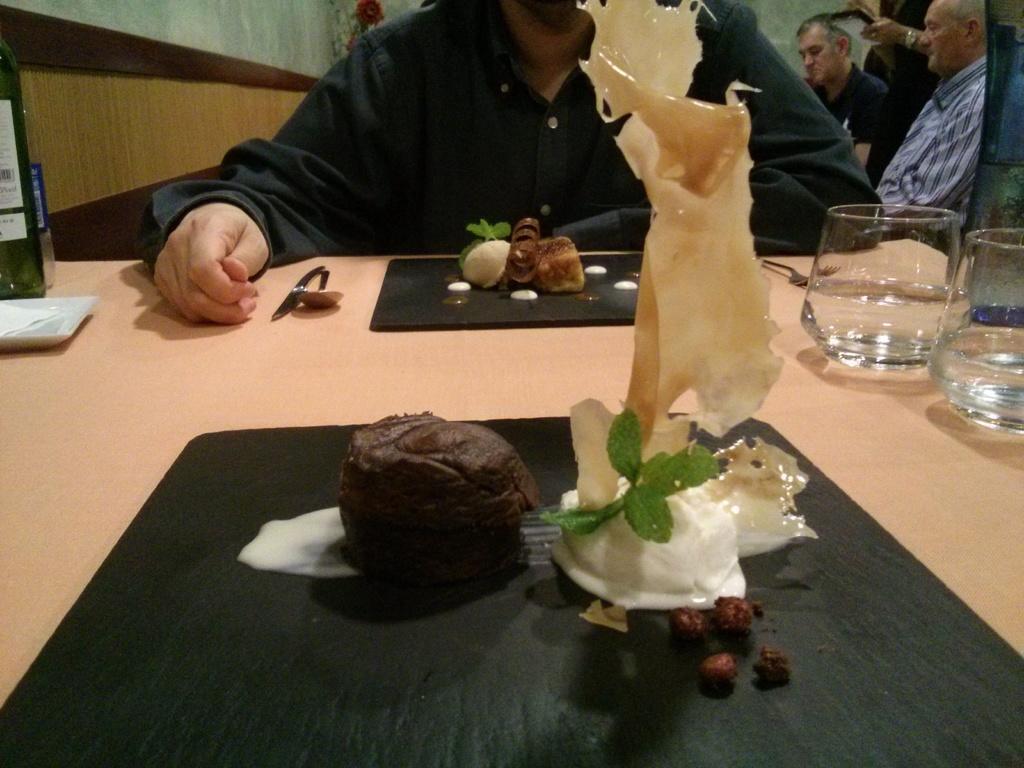Describe this image in one or two sentences. In the foreground of the picture there is a table, on the table there are glasses, bottle, plate, spoons and various food items. In the background there are people, wall, flower and other objects. 